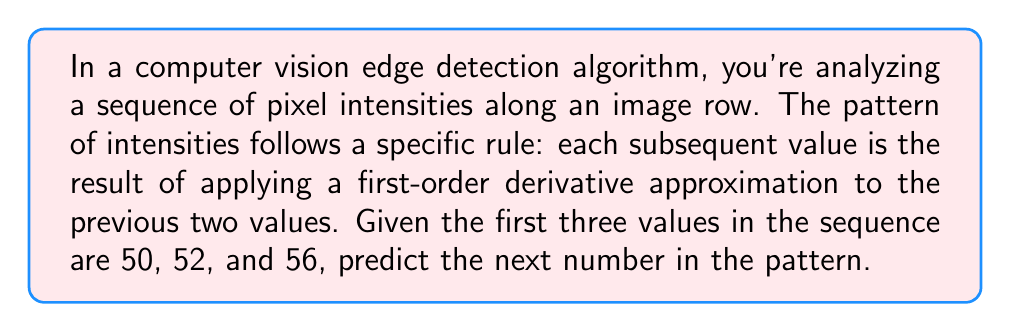Provide a solution to this math problem. Let's approach this step-by-step:

1) In edge detection, we often use gradient-based methods. The first-order derivative approximation is a common technique used to detect edges by finding rapid changes in intensity.

2) The first-order derivative can be approximated as the difference between adjacent pixel values.

3) Let's call our sequence $a_n$. We're given:
   $a_1 = 50$
   $a_2 = 52$
   $a_3 = 56$

4) The rule states that each subsequent value is the result of applying the first-order derivative approximation to the previous two values. In mathematical terms:
   $a_{n+1} = a_n + (a_n - a_{n-1})$

5) Let's verify this for $a_3$:
   $a_3 = a_2 + (a_2 - a_1) = 52 + (52 - 50) = 52 + 2 = 54$

6) Now, let's calculate $a_4$:
   $a_4 = a_3 + (a_3 - a_2)$
   $a_4 = 56 + (56 - 52)$
   $a_4 = 56 + 4 = 60$

Therefore, the next number in the sequence is 60.
Answer: 60 